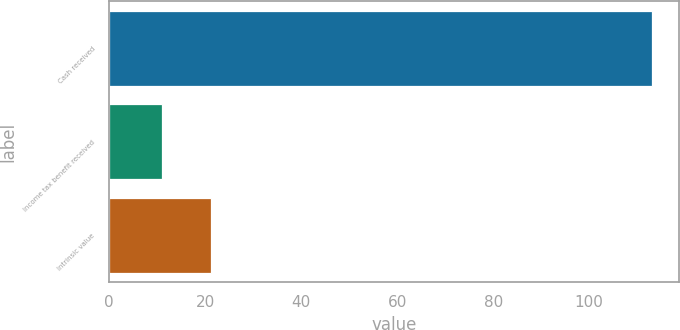Convert chart to OTSL. <chart><loc_0><loc_0><loc_500><loc_500><bar_chart><fcel>Cash received<fcel>Income tax benefit received<fcel>Intrinsic value<nl><fcel>113<fcel>11<fcel>21.2<nl></chart> 